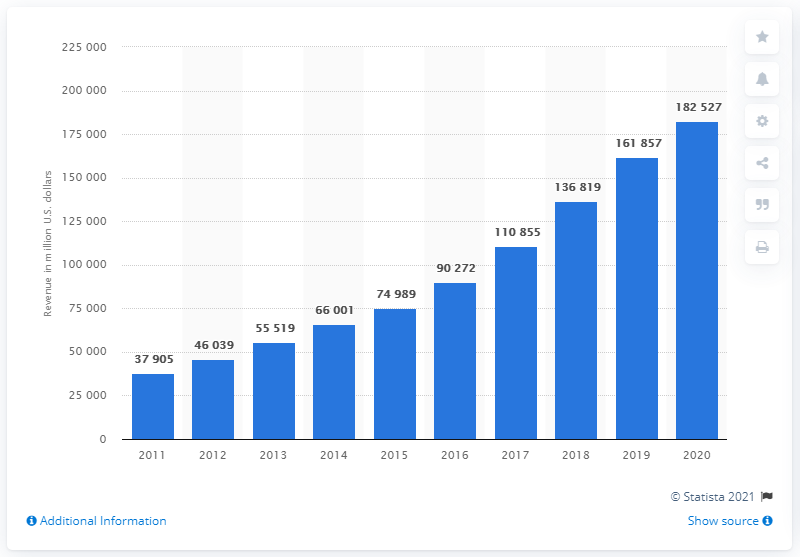Mention a couple of crucial points in this snapshot. Alphabet's revenue in the most recent fiscal year was 182,527. Alphabet reported revenue of $161,857.00 in the previous fiscal year. 